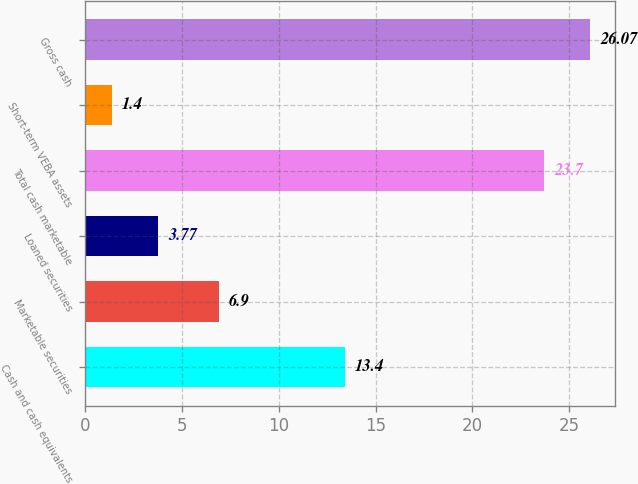Convert chart to OTSL. <chart><loc_0><loc_0><loc_500><loc_500><bar_chart><fcel>Cash and cash equivalents<fcel>Marketable securities<fcel>Loaned securities<fcel>Total cash marketable<fcel>Short-term VEBA assets<fcel>Gross cash<nl><fcel>13.4<fcel>6.9<fcel>3.77<fcel>23.7<fcel>1.4<fcel>26.07<nl></chart> 